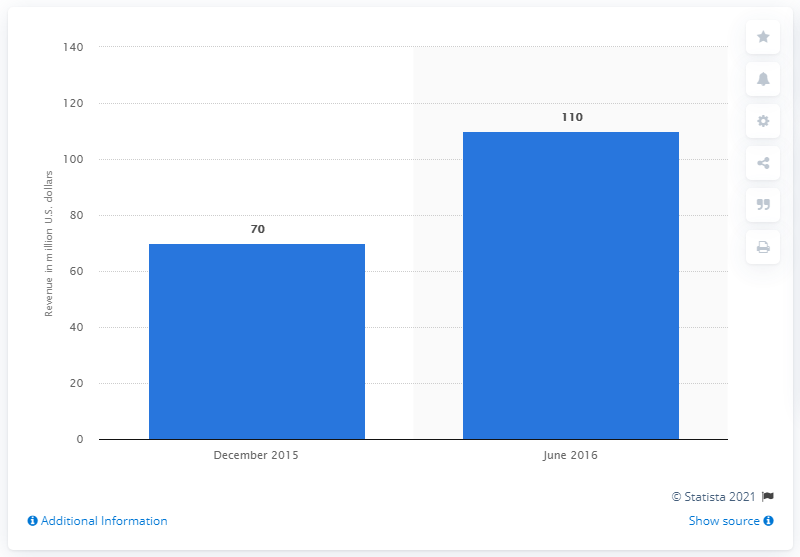Indicate a few pertinent items in this graphic. In June 2016, Rocket League generated approximately $110 million in revenue in the United States. Rocket League's sales revenue was released in June 2016. 